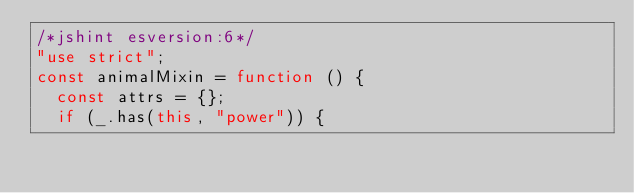<code> <loc_0><loc_0><loc_500><loc_500><_JavaScript_>/*jshint esversion:6*/
"use strict";
const animalMixin = function () {
  const attrs = {};
  if (_.has(this, "power")) {</code> 